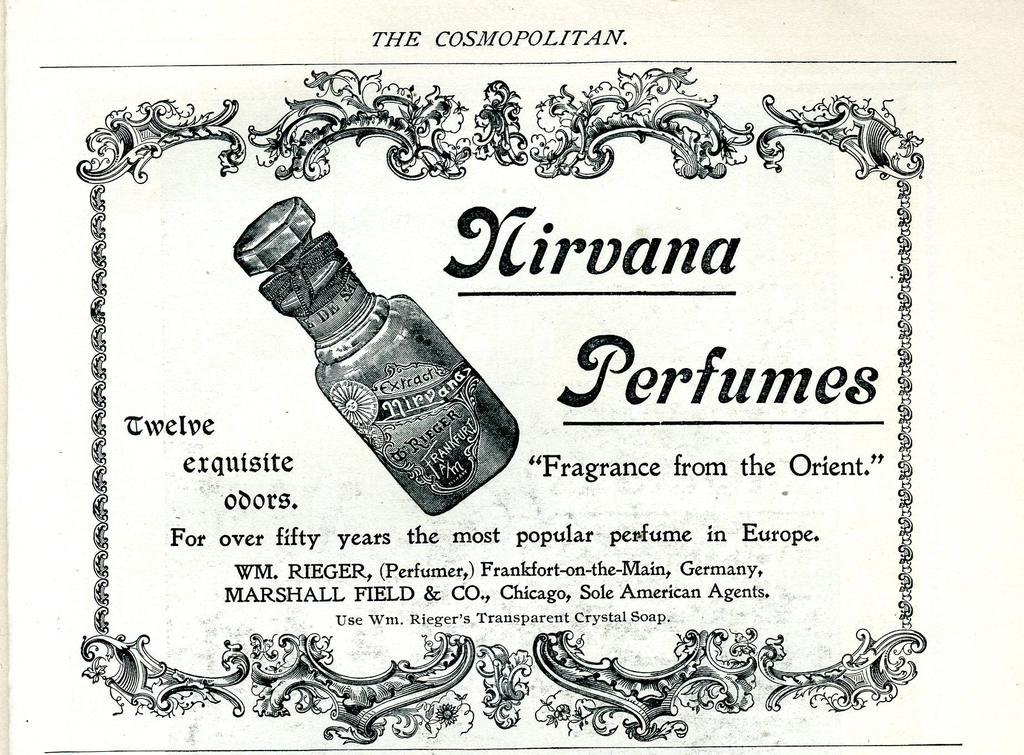What is the main object in the image? There is a paper in the image. What is depicted on the paper? The paper has a bottle printed on it. Are there any words or symbols on the paper? Yes, there is text on the paper. What else can be observed about the paper's appearance? The paper has a design along its borders. How do the lizards show respect to the bottle in the image? There are no lizards present in the image, so it is not possible to determine how they might show respect to the bottle. 